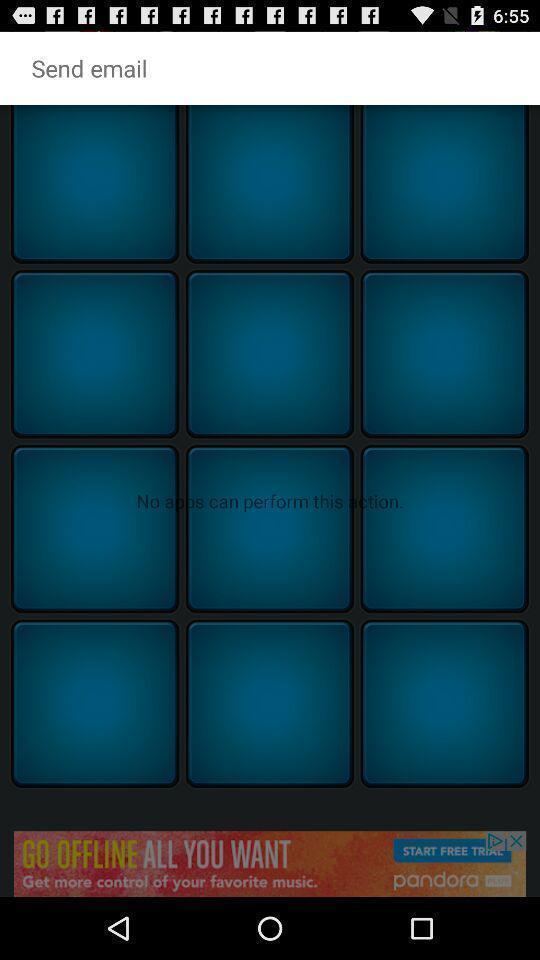What is the overall content of this screenshot? Screen displaying the page to send email. 